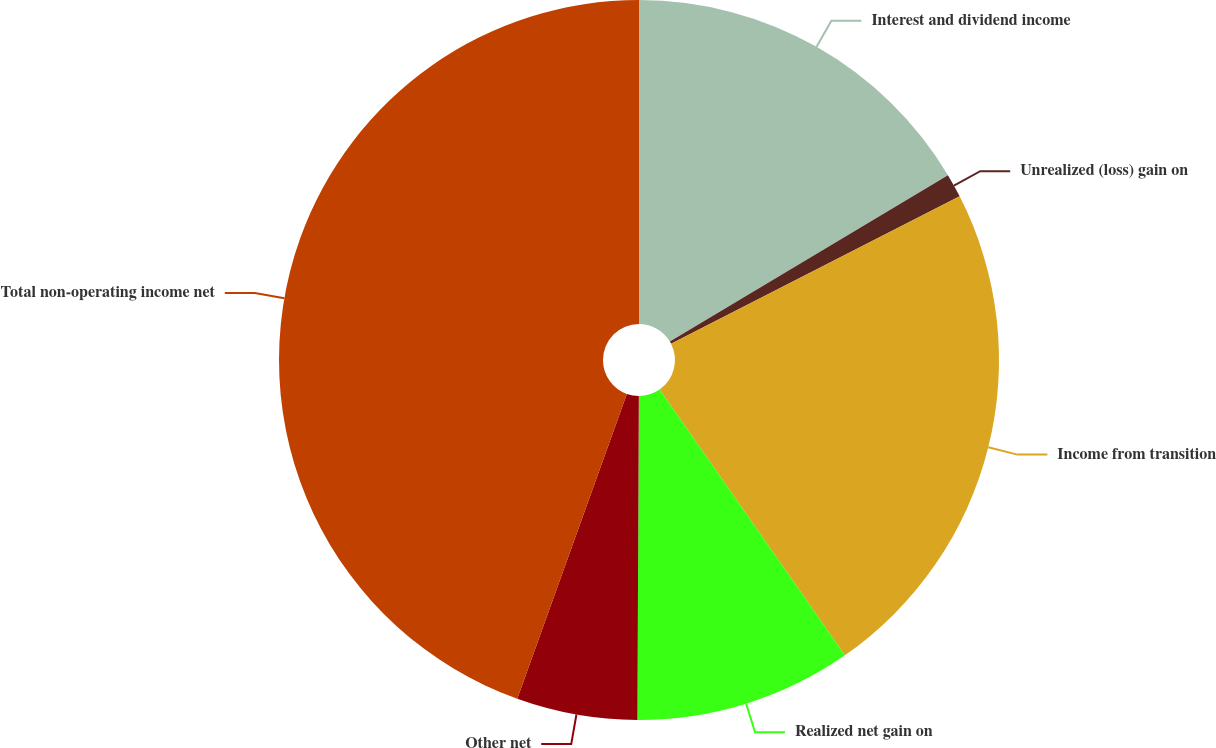Convert chart. <chart><loc_0><loc_0><loc_500><loc_500><pie_chart><fcel>Interest and dividend income<fcel>Unrealized (loss) gain on<fcel>Income from transition<fcel>Realized net gain on<fcel>Other net<fcel>Total non-operating income net<nl><fcel>16.42%<fcel>1.07%<fcel>22.82%<fcel>9.76%<fcel>5.42%<fcel>44.51%<nl></chart> 